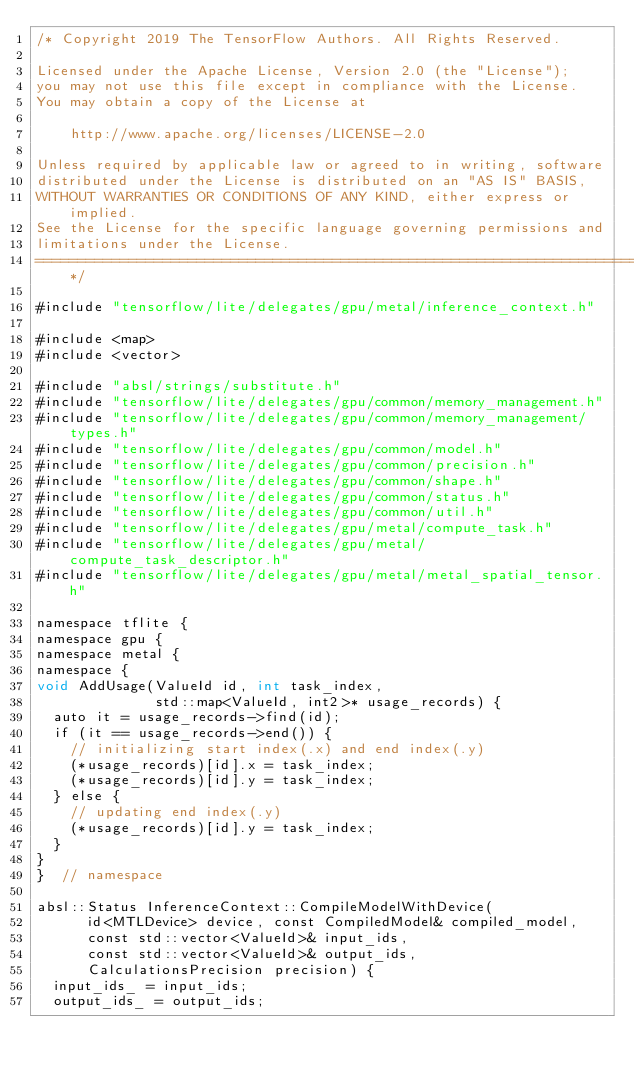Convert code to text. <code><loc_0><loc_0><loc_500><loc_500><_ObjectiveC_>/* Copyright 2019 The TensorFlow Authors. All Rights Reserved.

Licensed under the Apache License, Version 2.0 (the "License");
you may not use this file except in compliance with the License.
You may obtain a copy of the License at

    http://www.apache.org/licenses/LICENSE-2.0

Unless required by applicable law or agreed to in writing, software
distributed under the License is distributed on an "AS IS" BASIS,
WITHOUT WARRANTIES OR CONDITIONS OF ANY KIND, either express or implied.
See the License for the specific language governing permissions and
limitations under the License.
==============================================================================*/

#include "tensorflow/lite/delegates/gpu/metal/inference_context.h"

#include <map>
#include <vector>

#include "absl/strings/substitute.h"
#include "tensorflow/lite/delegates/gpu/common/memory_management.h"
#include "tensorflow/lite/delegates/gpu/common/memory_management/types.h"
#include "tensorflow/lite/delegates/gpu/common/model.h"
#include "tensorflow/lite/delegates/gpu/common/precision.h"
#include "tensorflow/lite/delegates/gpu/common/shape.h"
#include "tensorflow/lite/delegates/gpu/common/status.h"
#include "tensorflow/lite/delegates/gpu/common/util.h"
#include "tensorflow/lite/delegates/gpu/metal/compute_task.h"
#include "tensorflow/lite/delegates/gpu/metal/compute_task_descriptor.h"
#include "tensorflow/lite/delegates/gpu/metal/metal_spatial_tensor.h"

namespace tflite {
namespace gpu {
namespace metal {
namespace {
void AddUsage(ValueId id, int task_index,
              std::map<ValueId, int2>* usage_records) {
  auto it = usage_records->find(id);
  if (it == usage_records->end()) {
    // initializing start index(.x) and end index(.y)
    (*usage_records)[id].x = task_index;
    (*usage_records)[id].y = task_index;
  } else {
    // updating end index(.y)
    (*usage_records)[id].y = task_index;
  }
}
}  // namespace

absl::Status InferenceContext::CompileModelWithDevice(
      id<MTLDevice> device, const CompiledModel& compiled_model,
      const std::vector<ValueId>& input_ids,
      const std::vector<ValueId>& output_ids,
      CalculationsPrecision precision) {
  input_ids_ = input_ids;
  output_ids_ = output_ids;</code> 